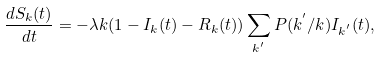Convert formula to latex. <formula><loc_0><loc_0><loc_500><loc_500>\frac { d S _ { k } ( t ) } { d t } = - \lambda k ( 1 - I _ { k } ( t ) - R _ { k } ( t ) ) \sum _ { k ^ { ^ { \prime } } } P ( k ^ { ^ { \prime } } / k ) I _ { k ^ { ^ { \prime } } } ( t ) ,</formula> 